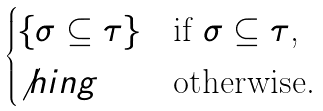Convert formula to latex. <formula><loc_0><loc_0><loc_500><loc_500>\begin{cases} \{ \sigma \subseteq \tau \} & \text {if $\sigma \subseteq \tau$,} \\ \not h i n g & \text {otherwise.} \end{cases}</formula> 